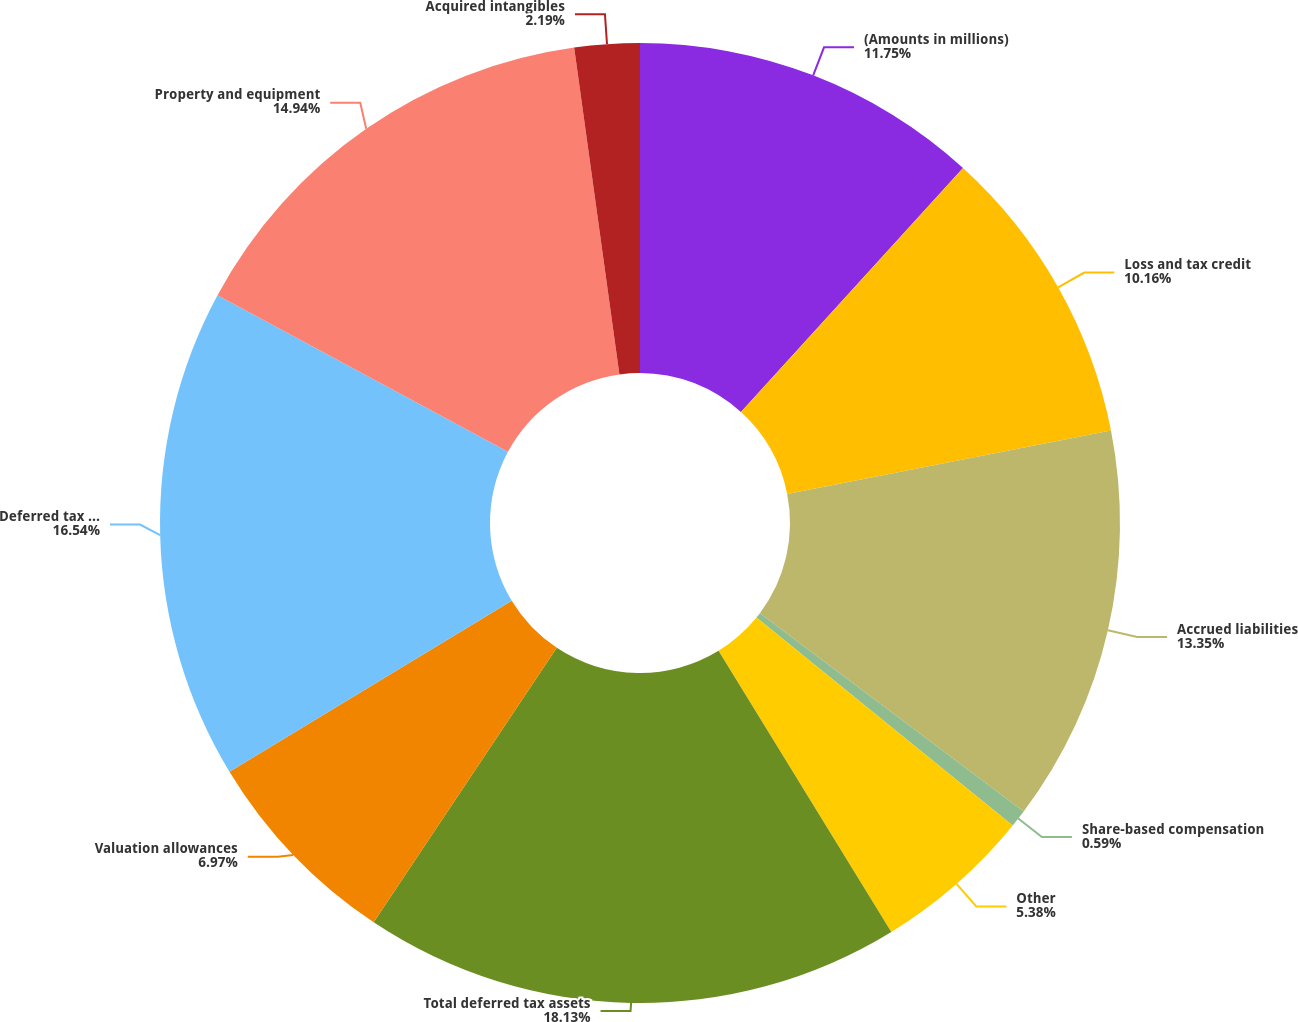<chart> <loc_0><loc_0><loc_500><loc_500><pie_chart><fcel>(Amounts in millions)<fcel>Loss and tax credit<fcel>Accrued liabilities<fcel>Share-based compensation<fcel>Other<fcel>Total deferred tax assets<fcel>Valuation allowances<fcel>Deferred tax assets net of<fcel>Property and equipment<fcel>Acquired intangibles<nl><fcel>11.75%<fcel>10.16%<fcel>13.35%<fcel>0.59%<fcel>5.38%<fcel>18.13%<fcel>6.97%<fcel>16.54%<fcel>14.94%<fcel>2.19%<nl></chart> 